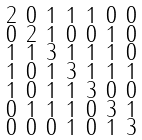<formula> <loc_0><loc_0><loc_500><loc_500>\begin{smallmatrix} 2 & 0 & 1 & 1 & 1 & 0 & 0 \\ 0 & 2 & 1 & 0 & 0 & 1 & 0 \\ 1 & 1 & 3 & 1 & 1 & 1 & 0 \\ 1 & 0 & 1 & 3 & 1 & 1 & 1 \\ 1 & 0 & 1 & 1 & 3 & 0 & 0 \\ 0 & 1 & 1 & 1 & 0 & 3 & 1 \\ 0 & 0 & 0 & 1 & 0 & 1 & 3 \end{smallmatrix}</formula> 